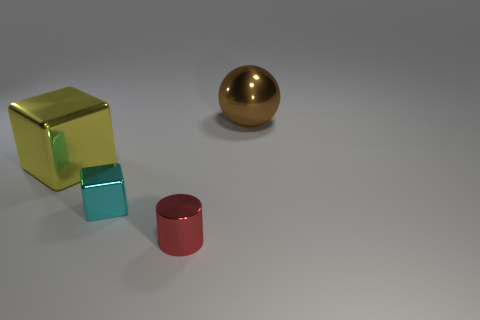The tiny metallic thing that is in front of the cyan thing has what shape?
Offer a very short reply. Cylinder. Do the large object that is on the left side of the big brown object and the object that is behind the large cube have the same material?
Provide a short and direct response. Yes. What is the shape of the tiny red thing?
Offer a very short reply. Cylinder. Is the number of large yellow shiny cubes that are in front of the shiny cylinder the same as the number of purple balls?
Give a very brief answer. Yes. Are there any cyan cubes made of the same material as the small cylinder?
Your answer should be very brief. Yes. Is the shape of the large object that is behind the big yellow shiny block the same as the big thing in front of the metallic ball?
Your answer should be very brief. No. Is there a big red rubber cube?
Your response must be concise. No. There is a block that is the same size as the brown sphere; what color is it?
Offer a terse response. Yellow. How many large brown things have the same shape as the yellow thing?
Offer a terse response. 0. How many balls are either large matte things or large brown metal objects?
Keep it short and to the point. 1. 